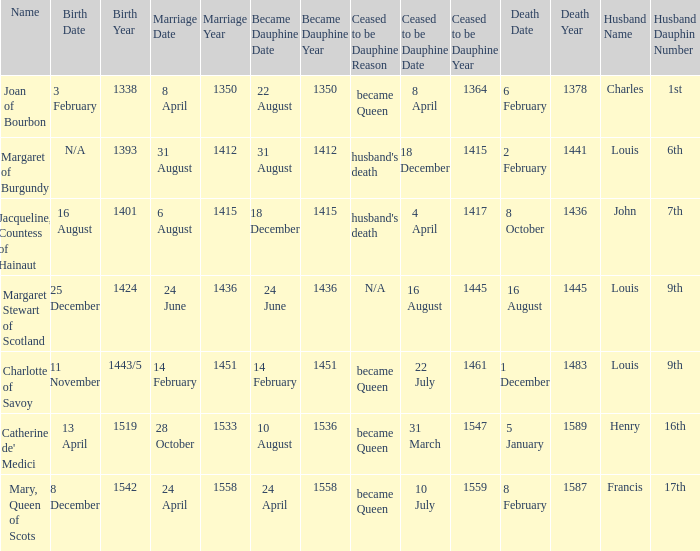Who is the husband when ceased to be dauphine is 22 july 1461 became queen? Louis, 9th Dauphin. 